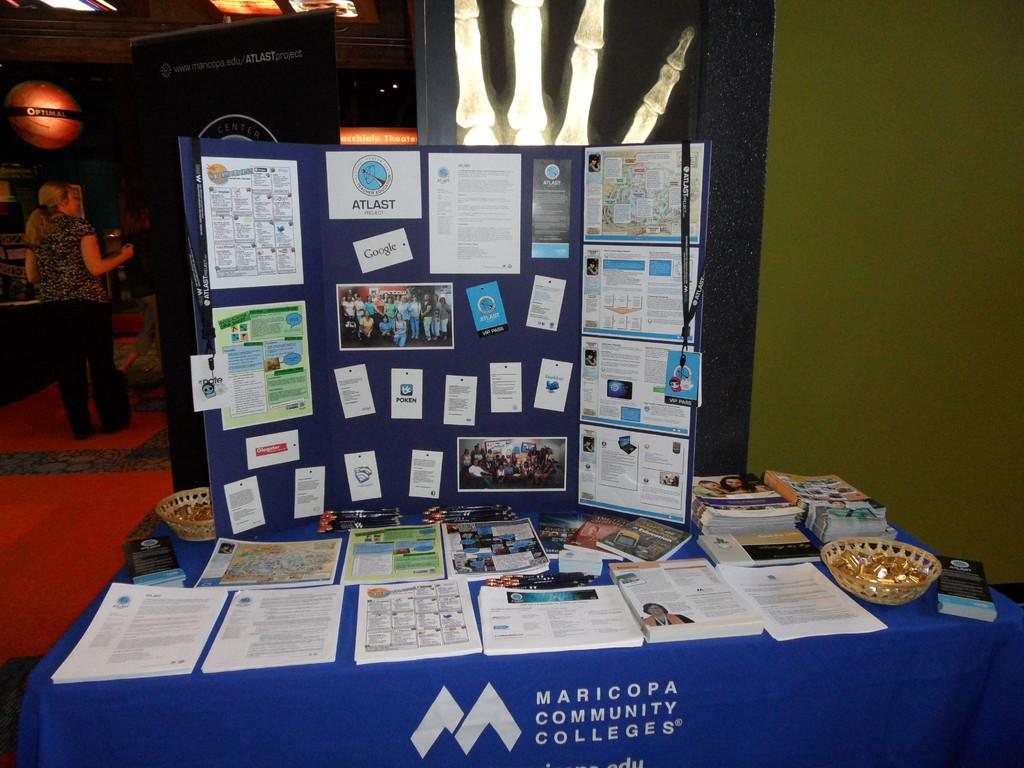What is located in the foreground of the image? There is a table in the foreground of the image. What is covering the table? The table is covered with a cloth. What objects can be seen on the table? There are books on the table. Can you describe the woman in the image? The woman is standing in the image, and she is on the left side of the image. What is the woman wearing? The woman is wearing clothes. What type of eggs can be seen in the image? There are no eggs present in the image. How many beds are visible in the image? There are no beds visible in the image. 